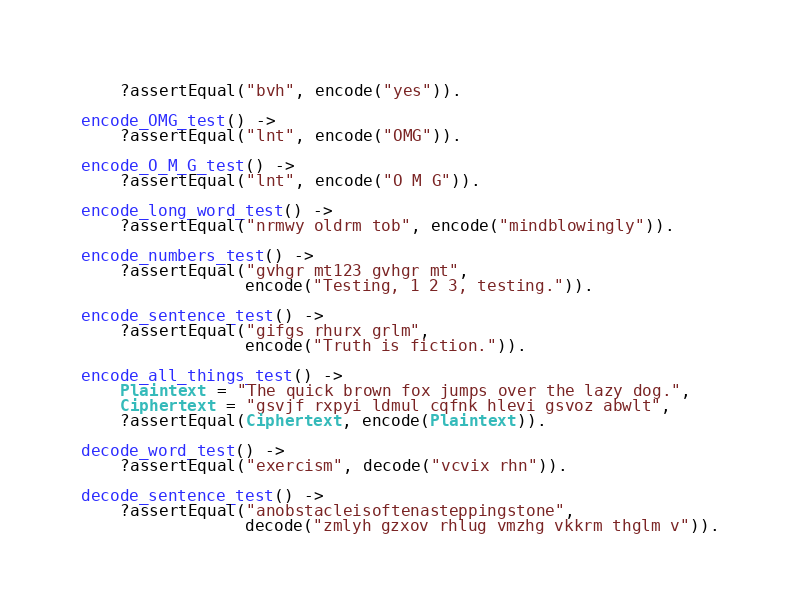Convert code to text. <code><loc_0><loc_0><loc_500><loc_500><_Erlang_>    ?assertEqual("bvh", encode("yes")).

encode_OMG_test() ->
    ?assertEqual("lnt", encode("OMG")).

encode_O_M_G_test() ->
    ?assertEqual("lnt", encode("O M G")).

encode_long_word_test() ->
    ?assertEqual("nrmwy oldrm tob", encode("mindblowingly")).

encode_numbers_test() ->
    ?assertEqual("gvhgr mt123 gvhgr mt",
                 encode("Testing, 1 2 3, testing.")).

encode_sentence_test() ->
    ?assertEqual("gifgs rhurx grlm",
                 encode("Truth is fiction.")).

encode_all_things_test() ->
    Plaintext = "The quick brown fox jumps over the lazy dog.",
    Ciphertext = "gsvjf rxpyi ldmul cqfnk hlevi gsvoz abwlt",
    ?assertEqual(Ciphertext, encode(Plaintext)).

decode_word_test() ->
    ?assertEqual("exercism", decode("vcvix rhn")).

decode_sentence_test() ->
    ?assertEqual("anobstacleisoftenasteppingstone",
                 decode("zmlyh gzxov rhlug vmzhg vkkrm thglm v")).
</code> 